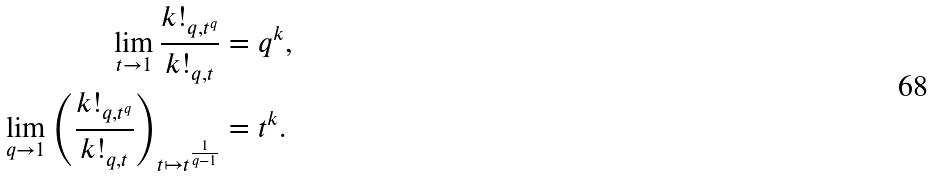Convert formula to latex. <formula><loc_0><loc_0><loc_500><loc_500>\lim _ { t \rightarrow 1 } \frac { k ! _ { q , t ^ { q } } } { k ! _ { q , t } } & = q ^ { k } , \\ \lim _ { q \rightarrow 1 } \left ( \frac { k ! _ { q , t ^ { q } } } { k ! _ { q , t } } \right ) _ { t \mapsto t ^ { \frac { 1 } { q - 1 } } } & = t ^ { k } .</formula> 